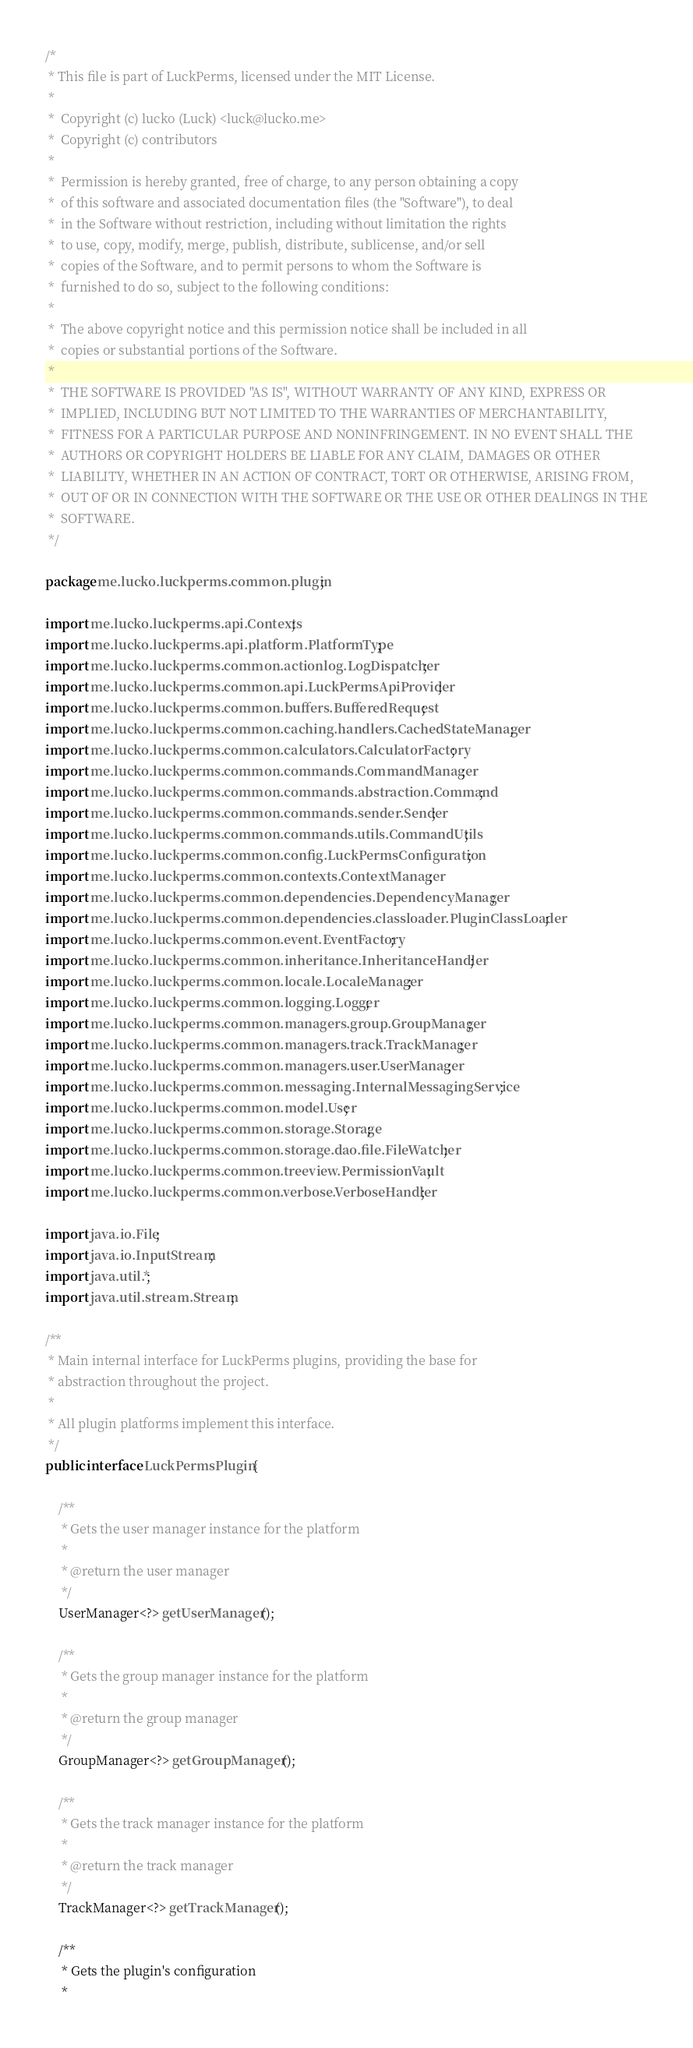Convert code to text. <code><loc_0><loc_0><loc_500><loc_500><_Java_>/*
 * This file is part of LuckPerms, licensed under the MIT License.
 *
 *  Copyright (c) lucko (Luck) <luck@lucko.me>
 *  Copyright (c) contributors
 *
 *  Permission is hereby granted, free of charge, to any person obtaining a copy
 *  of this software and associated documentation files (the "Software"), to deal
 *  in the Software without restriction, including without limitation the rights
 *  to use, copy, modify, merge, publish, distribute, sublicense, and/or sell
 *  copies of the Software, and to permit persons to whom the Software is
 *  furnished to do so, subject to the following conditions:
 *
 *  The above copyright notice and this permission notice shall be included in all
 *  copies or substantial portions of the Software.
 *
 *  THE SOFTWARE IS PROVIDED "AS IS", WITHOUT WARRANTY OF ANY KIND, EXPRESS OR
 *  IMPLIED, INCLUDING BUT NOT LIMITED TO THE WARRANTIES OF MERCHANTABILITY,
 *  FITNESS FOR A PARTICULAR PURPOSE AND NONINFRINGEMENT. IN NO EVENT SHALL THE
 *  AUTHORS OR COPYRIGHT HOLDERS BE LIABLE FOR ANY CLAIM, DAMAGES OR OTHER
 *  LIABILITY, WHETHER IN AN ACTION OF CONTRACT, TORT OR OTHERWISE, ARISING FROM,
 *  OUT OF OR IN CONNECTION WITH THE SOFTWARE OR THE USE OR OTHER DEALINGS IN THE
 *  SOFTWARE.
 */

package me.lucko.luckperms.common.plugin;

import me.lucko.luckperms.api.Contexts;
import me.lucko.luckperms.api.platform.PlatformType;
import me.lucko.luckperms.common.actionlog.LogDispatcher;
import me.lucko.luckperms.common.api.LuckPermsApiProvider;
import me.lucko.luckperms.common.buffers.BufferedRequest;
import me.lucko.luckperms.common.caching.handlers.CachedStateManager;
import me.lucko.luckperms.common.calculators.CalculatorFactory;
import me.lucko.luckperms.common.commands.CommandManager;
import me.lucko.luckperms.common.commands.abstraction.Command;
import me.lucko.luckperms.common.commands.sender.Sender;
import me.lucko.luckperms.common.commands.utils.CommandUtils;
import me.lucko.luckperms.common.config.LuckPermsConfiguration;
import me.lucko.luckperms.common.contexts.ContextManager;
import me.lucko.luckperms.common.dependencies.DependencyManager;
import me.lucko.luckperms.common.dependencies.classloader.PluginClassLoader;
import me.lucko.luckperms.common.event.EventFactory;
import me.lucko.luckperms.common.inheritance.InheritanceHandler;
import me.lucko.luckperms.common.locale.LocaleManager;
import me.lucko.luckperms.common.logging.Logger;
import me.lucko.luckperms.common.managers.group.GroupManager;
import me.lucko.luckperms.common.managers.track.TrackManager;
import me.lucko.luckperms.common.managers.user.UserManager;
import me.lucko.luckperms.common.messaging.InternalMessagingService;
import me.lucko.luckperms.common.model.User;
import me.lucko.luckperms.common.storage.Storage;
import me.lucko.luckperms.common.storage.dao.file.FileWatcher;
import me.lucko.luckperms.common.treeview.PermissionVault;
import me.lucko.luckperms.common.verbose.VerboseHandler;

import java.io.File;
import java.io.InputStream;
import java.util.*;
import java.util.stream.Stream;

/**
 * Main internal interface for LuckPerms plugins, providing the base for
 * abstraction throughout the project.
 *
 * All plugin platforms implement this interface.
 */
public interface LuckPermsPlugin {

    /**
     * Gets the user manager instance for the platform
     *
     * @return the user manager
     */
    UserManager<?> getUserManager();

    /**
     * Gets the group manager instance for the platform
     *
     * @return the group manager
     */
    GroupManager<?> getGroupManager();

    /**
     * Gets the track manager instance for the platform
     *
     * @return the track manager
     */
    TrackManager<?> getTrackManager();

    /**
     * Gets the plugin's configuration
     *</code> 